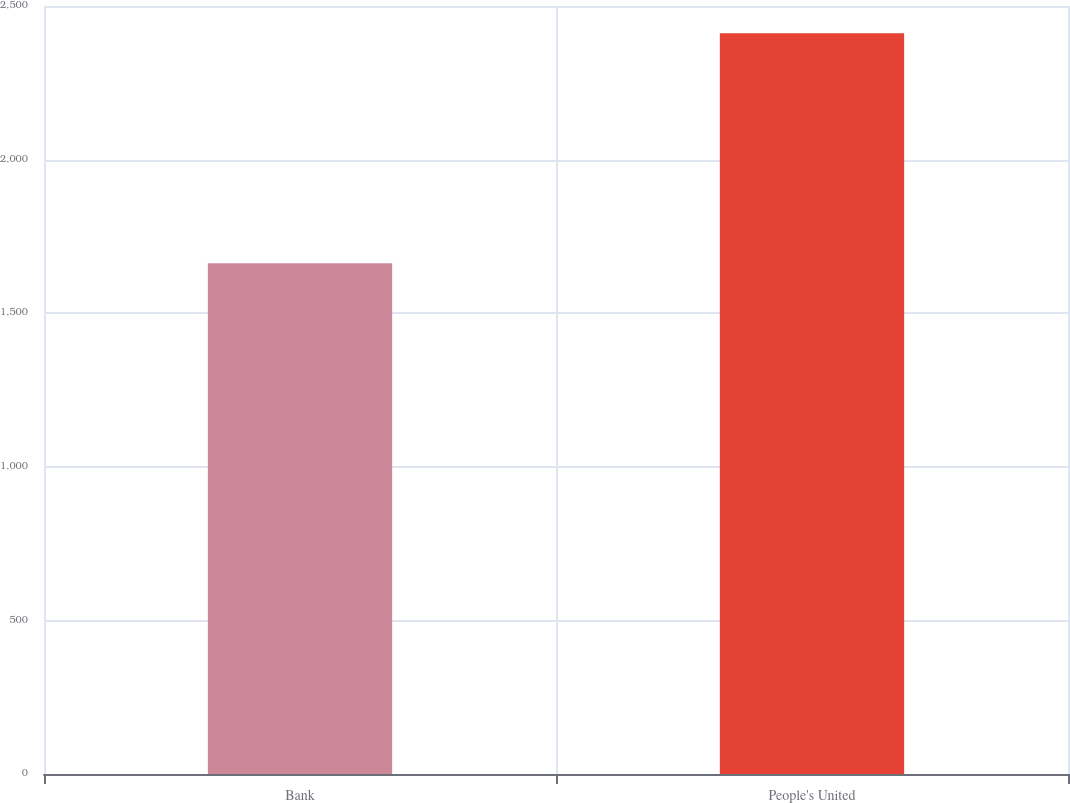Convert chart. <chart><loc_0><loc_0><loc_500><loc_500><bar_chart><fcel>Bank<fcel>People's United<nl><fcel>1663<fcel>2411.1<nl></chart> 